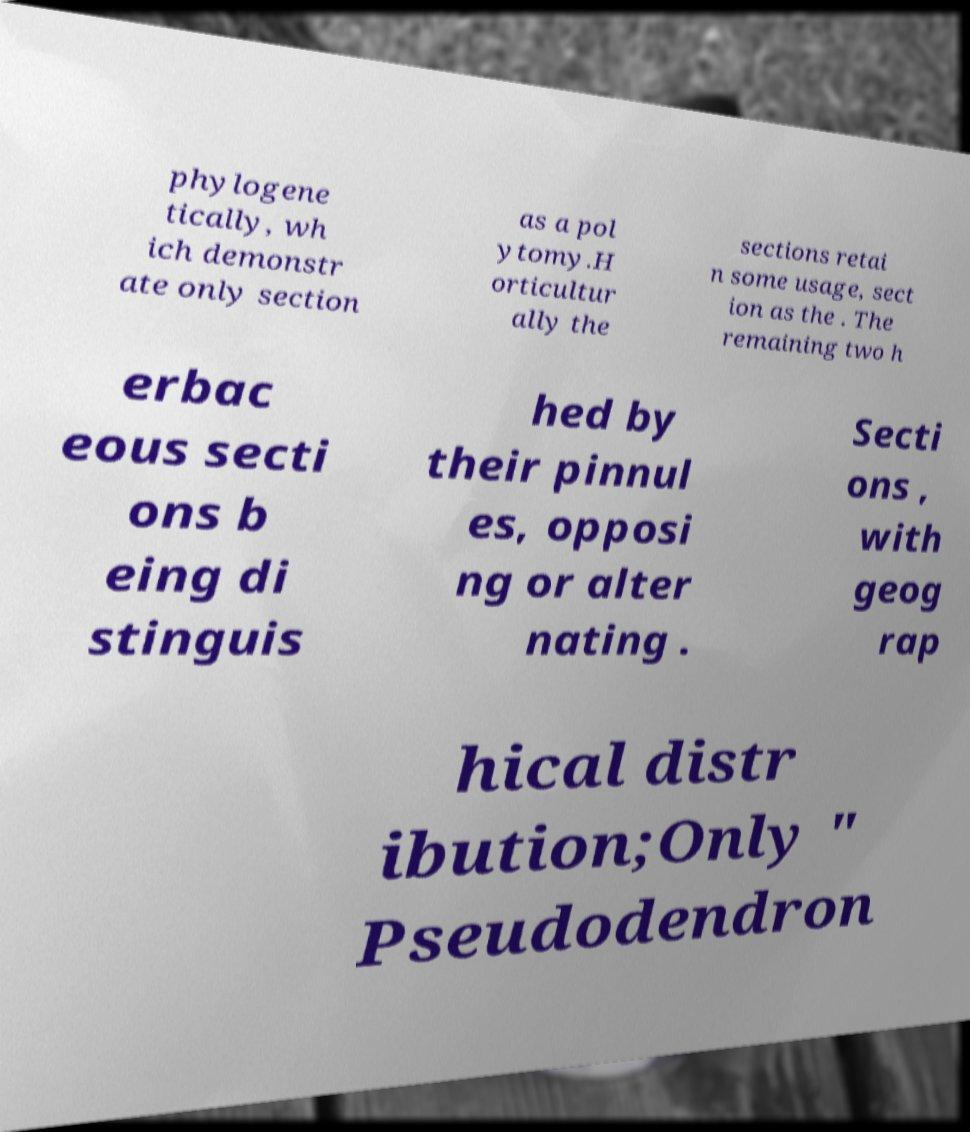There's text embedded in this image that I need extracted. Can you transcribe it verbatim? phylogene tically, wh ich demonstr ate only section as a pol ytomy.H orticultur ally the sections retai n some usage, sect ion as the . The remaining two h erbac eous secti ons b eing di stinguis hed by their pinnul es, opposi ng or alter nating . Secti ons , with geog rap hical distr ibution;Only " Pseudodendron 